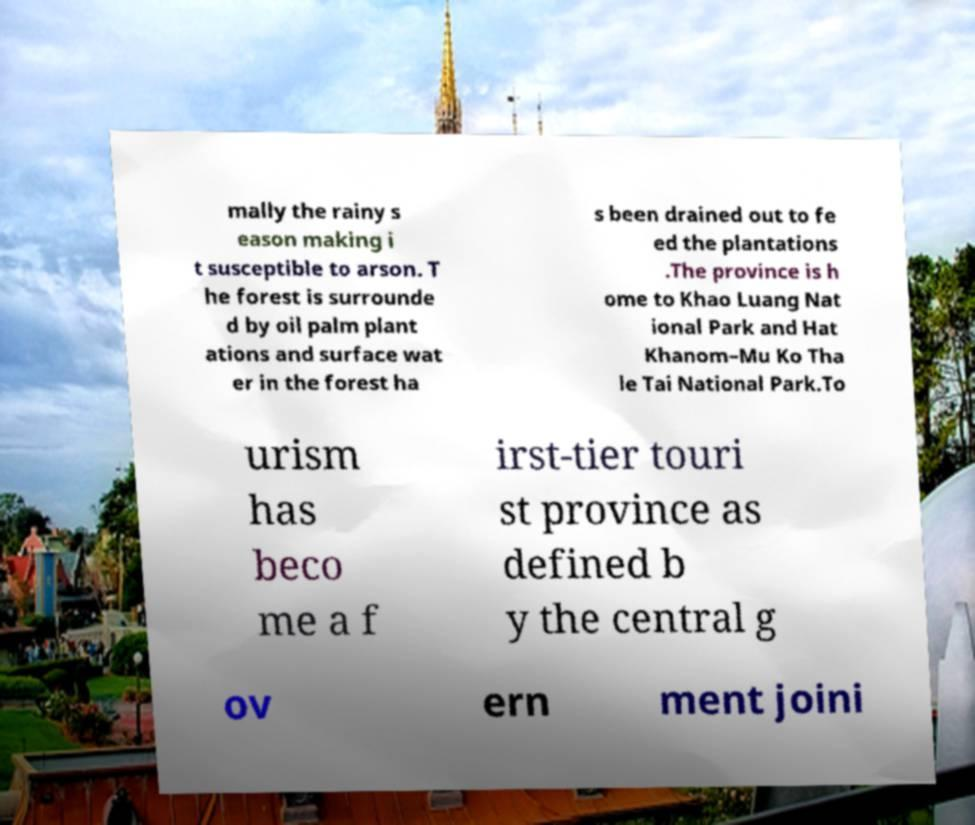Please read and relay the text visible in this image. What does it say? mally the rainy s eason making i t susceptible to arson. T he forest is surrounde d by oil palm plant ations and surface wat er in the forest ha s been drained out to fe ed the plantations .The province is h ome to Khao Luang Nat ional Park and Hat Khanom–Mu Ko Tha le Tai National Park.To urism has beco me a f irst-tier touri st province as defined b y the central g ov ern ment joini 